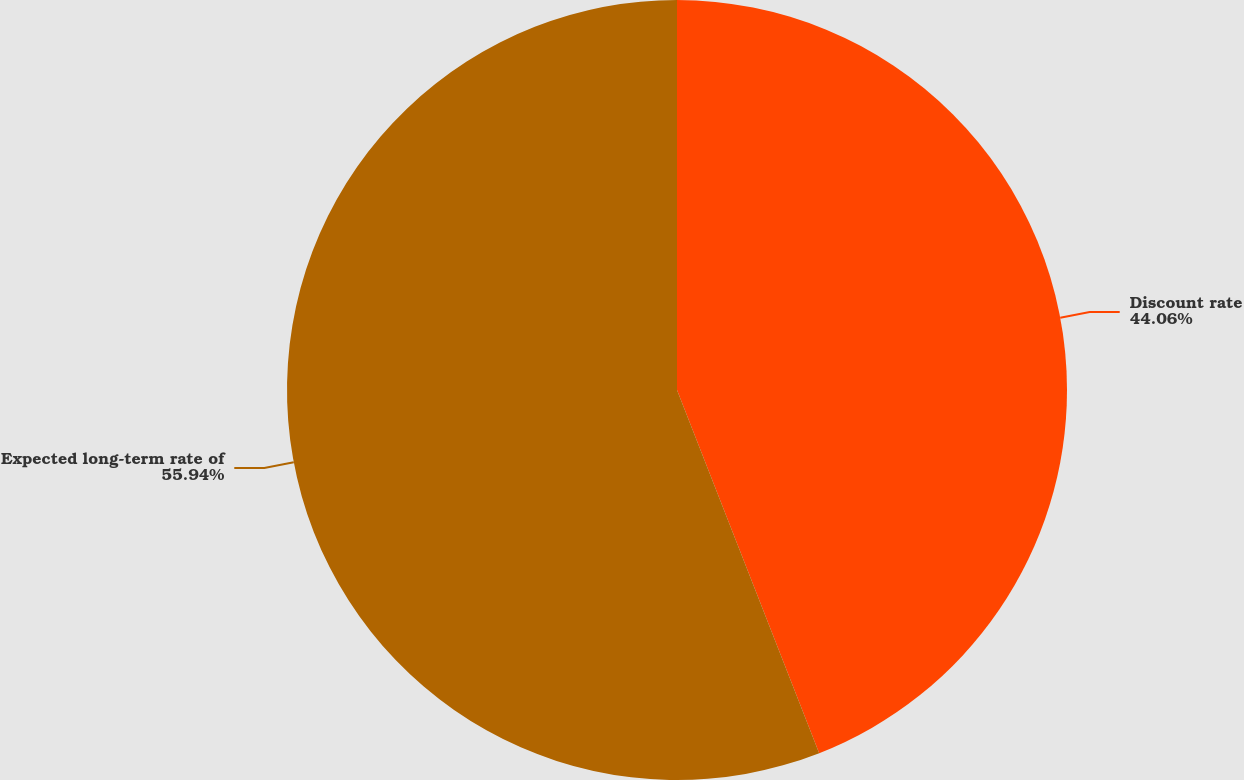Convert chart. <chart><loc_0><loc_0><loc_500><loc_500><pie_chart><fcel>Discount rate<fcel>Expected long-term rate of<nl><fcel>44.06%<fcel>55.94%<nl></chart> 